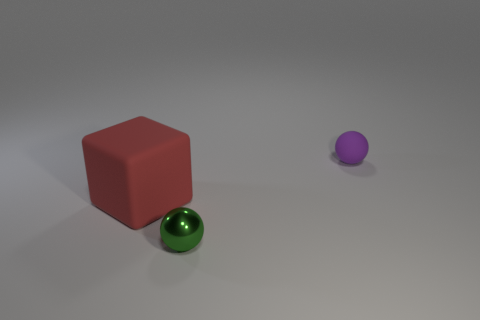There is a red thing that is made of the same material as the tiny purple thing; what is its size?
Provide a succinct answer. Large. What number of other tiny purple things are the same shape as the metallic object?
Offer a very short reply. 1. Are there any other things that are the same size as the red matte block?
Provide a succinct answer. No. There is a ball that is behind the tiny object that is left of the small purple rubber ball; what size is it?
Your response must be concise. Small. There is a purple thing that is the same size as the metallic ball; what is it made of?
Your answer should be very brief. Rubber. Is there a big sphere that has the same material as the tiny green object?
Offer a very short reply. No. There is a matte thing that is in front of the tiny sphere on the right side of the sphere that is in front of the block; what color is it?
Ensure brevity in your answer.  Red. Does the tiny object behind the red matte object have the same color as the thing that is on the left side of the tiny green thing?
Your answer should be compact. No. Is there any other thing that is the same color as the big cube?
Keep it short and to the point. No. Are there fewer tiny green balls that are behind the purple rubber ball than large yellow rubber spheres?
Provide a succinct answer. No. 